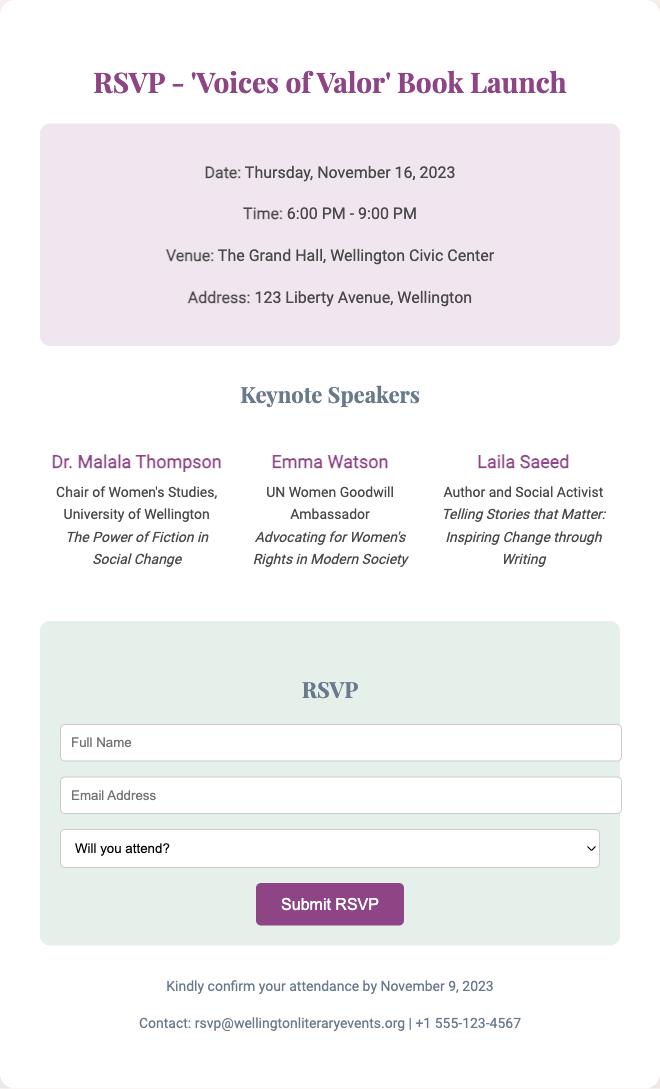What is the name of the event? The name of the event is indicated in the title of the RSVP card, which is 'Voices of Valor' Book Launch.
Answer: 'Voices of Valor' What is the date of the book launch? The date is provided in the event details section of the RSVP card, which states "Thursday, November 16, 2023."
Answer: Thursday, November 16, 2023 Where is the venue located? The venue is specified in the event details, mentioning "The Grand Hall, Wellington Civic Center."
Answer: The Grand Hall, Wellington Civic Center Who is one of the keynote speakers? The speakers are mentioned in the Keynote Speakers section, with names provided, such as "Dr. Malala Thompson."
Answer: Dr. Malala Thompson What time does the event start? The start time is included in the event details section, stating "6:00 PM."
Answer: 6:00 PM What is the deadline to RSVP? The RSVP deadline is outlined in the additional info section, which states to confirm attendance by November 9, 2023.
Answer: November 9, 2023 What is the email contact for the event? The contact information section provides an email, which is "rsvp@wellingtonliteraryevents.org."
Answer: rsvp@wellingtonliteraryevents.org What is the purpose of this RSVP card? The primary purpose is to gather responses regarding attendance for the book launch event, particularly for 'Voices of Valor.'
Answer: To gather responses for attendance How many keynote speakers are listed? The document contains a section listing the names of the speakers, which includes three individuals.
Answer: Three 